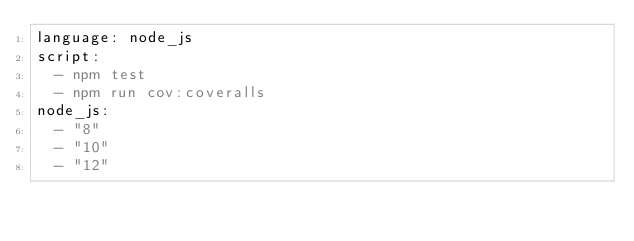Convert code to text. <code><loc_0><loc_0><loc_500><loc_500><_YAML_>language: node_js
script:
  - npm test
  - npm run cov:coveralls
node_js:
  - "8"
  - "10"
  - "12"
</code> 